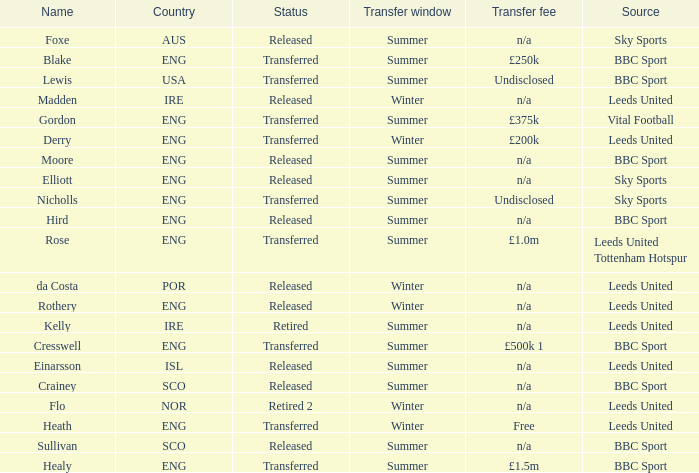What was the source for the person named Cresswell? BBC Sport. 